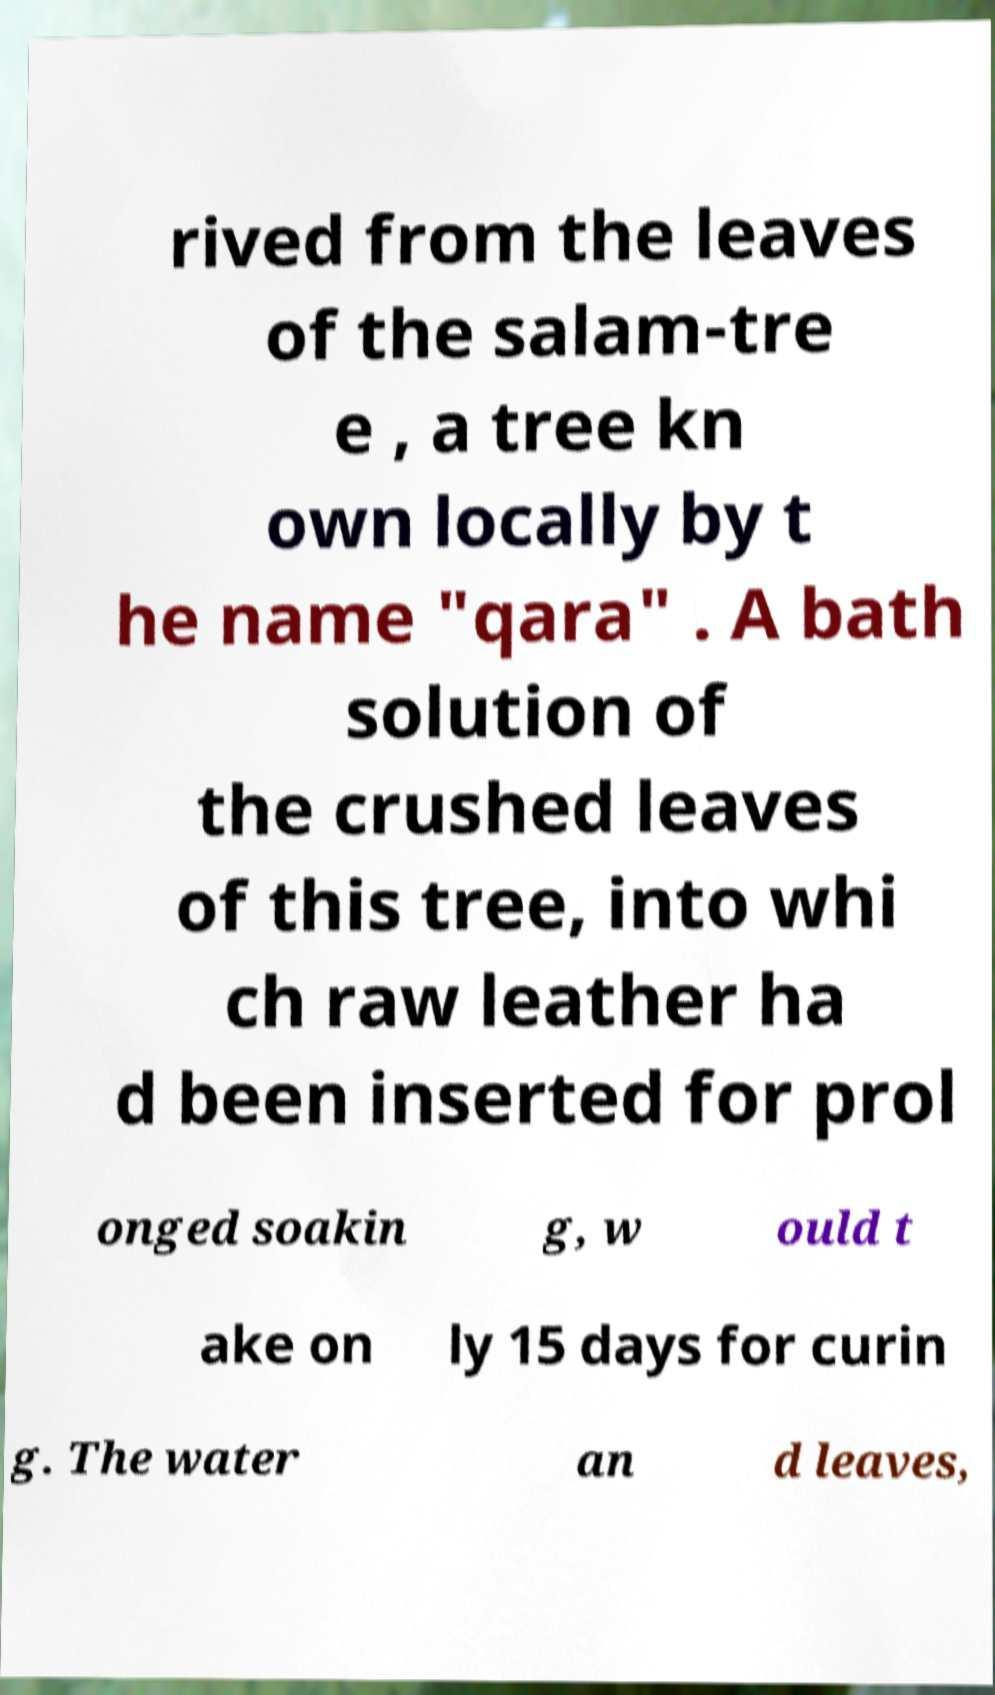Could you extract and type out the text from this image? rived from the leaves of the salam-tre e , a tree kn own locally by t he name "qara" . A bath solution of the crushed leaves of this tree, into whi ch raw leather ha d been inserted for prol onged soakin g, w ould t ake on ly 15 days for curin g. The water an d leaves, 